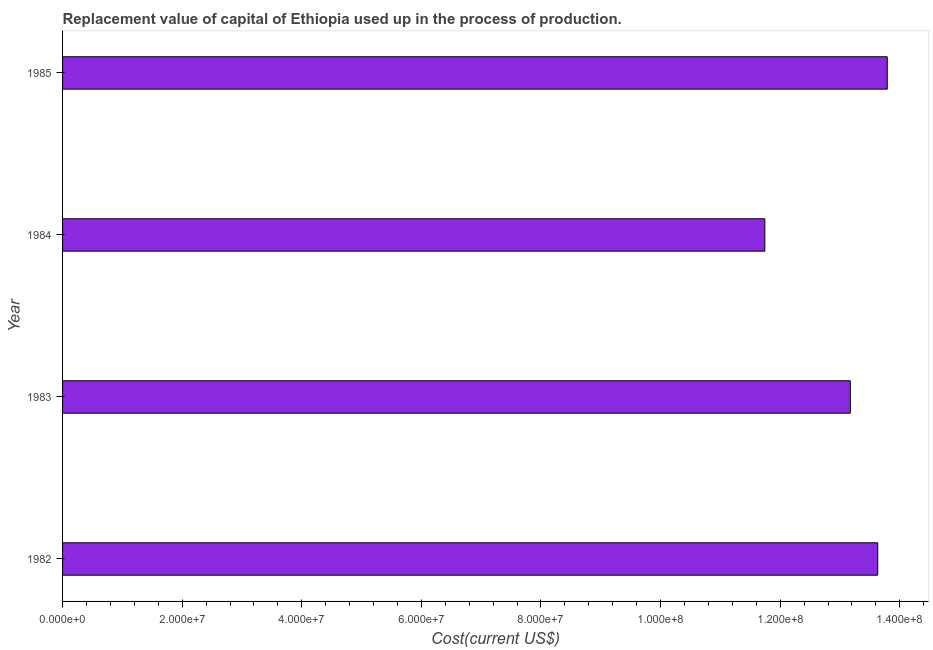Does the graph contain any zero values?
Keep it short and to the point. No. What is the title of the graph?
Provide a succinct answer. Replacement value of capital of Ethiopia used up in the process of production. What is the label or title of the X-axis?
Ensure brevity in your answer.  Cost(current US$). What is the consumption of fixed capital in 1984?
Provide a short and direct response. 1.17e+08. Across all years, what is the maximum consumption of fixed capital?
Offer a terse response. 1.38e+08. Across all years, what is the minimum consumption of fixed capital?
Offer a terse response. 1.17e+08. In which year was the consumption of fixed capital maximum?
Keep it short and to the point. 1985. What is the sum of the consumption of fixed capital?
Your answer should be compact. 5.23e+08. What is the difference between the consumption of fixed capital in 1983 and 1985?
Ensure brevity in your answer.  -6.18e+06. What is the average consumption of fixed capital per year?
Your response must be concise. 1.31e+08. What is the median consumption of fixed capital?
Provide a succinct answer. 1.34e+08. In how many years, is the consumption of fixed capital greater than 112000000 US$?
Offer a very short reply. 4. Do a majority of the years between 1982 and 1983 (inclusive) have consumption of fixed capital greater than 56000000 US$?
Keep it short and to the point. Yes. What is the ratio of the consumption of fixed capital in 1982 to that in 1983?
Your answer should be very brief. 1.03. Is the difference between the consumption of fixed capital in 1982 and 1983 greater than the difference between any two years?
Ensure brevity in your answer.  No. What is the difference between the highest and the second highest consumption of fixed capital?
Ensure brevity in your answer.  1.59e+06. What is the difference between the highest and the lowest consumption of fixed capital?
Provide a short and direct response. 2.05e+07. How many bars are there?
Provide a short and direct response. 4. How many years are there in the graph?
Offer a terse response. 4. What is the Cost(current US$) in 1982?
Your answer should be compact. 1.36e+08. What is the Cost(current US$) of 1983?
Provide a short and direct response. 1.32e+08. What is the Cost(current US$) of 1984?
Offer a very short reply. 1.17e+08. What is the Cost(current US$) of 1985?
Keep it short and to the point. 1.38e+08. What is the difference between the Cost(current US$) in 1982 and 1983?
Your answer should be very brief. 4.58e+06. What is the difference between the Cost(current US$) in 1982 and 1984?
Give a very brief answer. 1.89e+07. What is the difference between the Cost(current US$) in 1982 and 1985?
Provide a succinct answer. -1.59e+06. What is the difference between the Cost(current US$) in 1983 and 1984?
Ensure brevity in your answer.  1.43e+07. What is the difference between the Cost(current US$) in 1983 and 1985?
Your answer should be compact. -6.18e+06. What is the difference between the Cost(current US$) in 1984 and 1985?
Ensure brevity in your answer.  -2.05e+07. What is the ratio of the Cost(current US$) in 1982 to that in 1983?
Make the answer very short. 1.03. What is the ratio of the Cost(current US$) in 1982 to that in 1984?
Your answer should be very brief. 1.16. What is the ratio of the Cost(current US$) in 1983 to that in 1984?
Your response must be concise. 1.12. What is the ratio of the Cost(current US$) in 1983 to that in 1985?
Offer a very short reply. 0.95. What is the ratio of the Cost(current US$) in 1984 to that in 1985?
Your response must be concise. 0.85. 